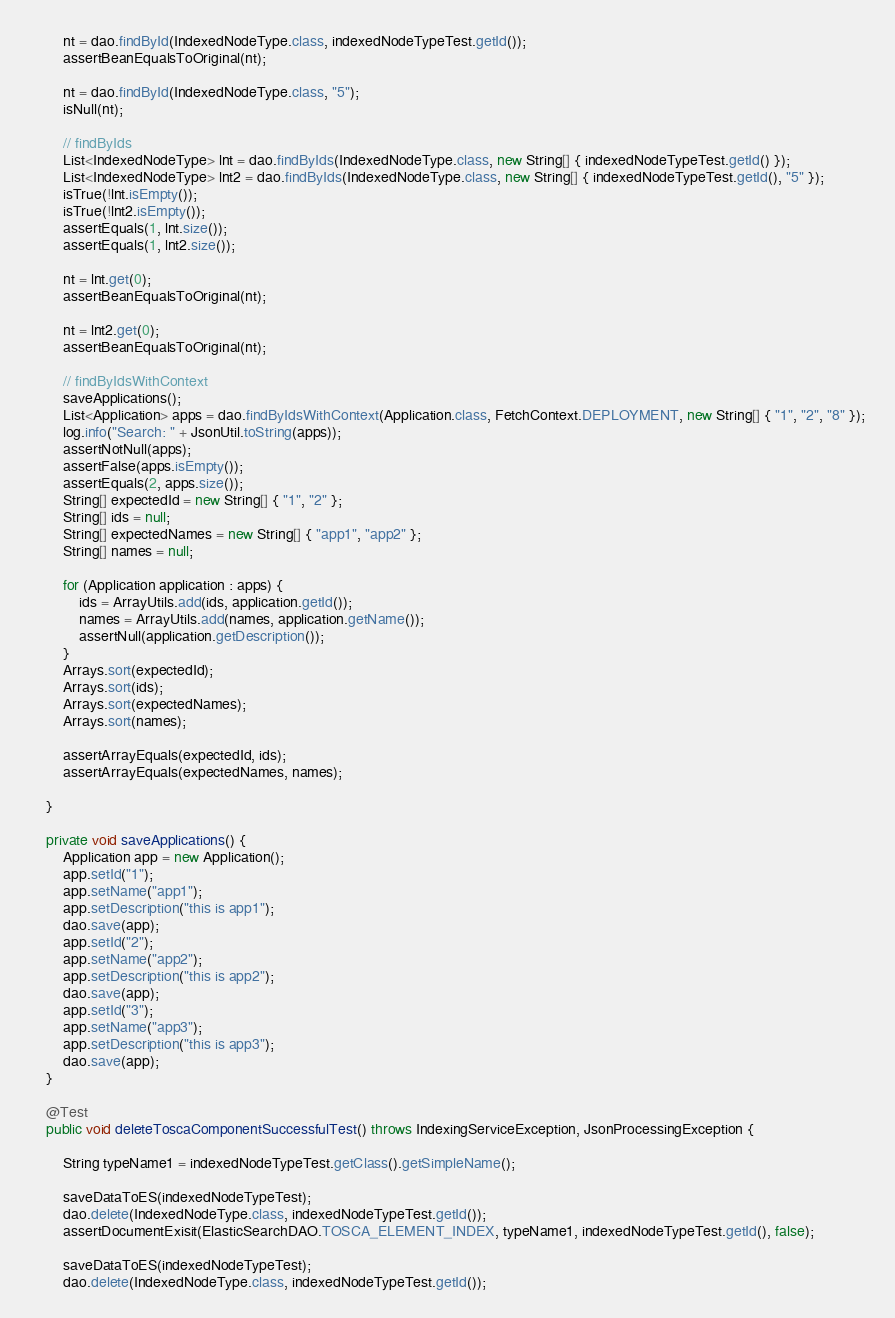<code> <loc_0><loc_0><loc_500><loc_500><_Java_>
        nt = dao.findById(IndexedNodeType.class, indexedNodeTypeTest.getId());
        assertBeanEqualsToOriginal(nt);

        nt = dao.findById(IndexedNodeType.class, "5");
        isNull(nt);

        // findByIds
        List<IndexedNodeType> lnt = dao.findByIds(IndexedNodeType.class, new String[] { indexedNodeTypeTest.getId() });
        List<IndexedNodeType> lnt2 = dao.findByIds(IndexedNodeType.class, new String[] { indexedNodeTypeTest.getId(), "5" });
        isTrue(!lnt.isEmpty());
        isTrue(!lnt2.isEmpty());
        assertEquals(1, lnt.size());
        assertEquals(1, lnt2.size());

        nt = lnt.get(0);
        assertBeanEqualsToOriginal(nt);

        nt = lnt2.get(0);
        assertBeanEqualsToOriginal(nt);

        // findByIdsWithContext
        saveApplications();
        List<Application> apps = dao.findByIdsWithContext(Application.class, FetchContext.DEPLOYMENT, new String[] { "1", "2", "8" });
        log.info("Search: " + JsonUtil.toString(apps));
        assertNotNull(apps);
        assertFalse(apps.isEmpty());
        assertEquals(2, apps.size());
        String[] expectedId = new String[] { "1", "2" };
        String[] ids = null;
        String[] expectedNames = new String[] { "app1", "app2" };
        String[] names = null;

        for (Application application : apps) {
            ids = ArrayUtils.add(ids, application.getId());
            names = ArrayUtils.add(names, application.getName());
            assertNull(application.getDescription());
        }
        Arrays.sort(expectedId);
        Arrays.sort(ids);
        Arrays.sort(expectedNames);
        Arrays.sort(names);

        assertArrayEquals(expectedId, ids);
        assertArrayEquals(expectedNames, names);

    }

    private void saveApplications() {
        Application app = new Application();
        app.setId("1");
        app.setName("app1");
        app.setDescription("this is app1");
        dao.save(app);
        app.setId("2");
        app.setName("app2");
        app.setDescription("this is app2");
        dao.save(app);
        app.setId("3");
        app.setName("app3");
        app.setDescription("this is app3");
        dao.save(app);
    }

    @Test
    public void deleteToscaComponentSuccessfulTest() throws IndexingServiceException, JsonProcessingException {

        String typeName1 = indexedNodeTypeTest.getClass().getSimpleName();

        saveDataToES(indexedNodeTypeTest);
        dao.delete(IndexedNodeType.class, indexedNodeTypeTest.getId());
        assertDocumentExisit(ElasticSearchDAO.TOSCA_ELEMENT_INDEX, typeName1, indexedNodeTypeTest.getId(), false);

        saveDataToES(indexedNodeTypeTest);
        dao.delete(IndexedNodeType.class, indexedNodeTypeTest.getId());</code> 